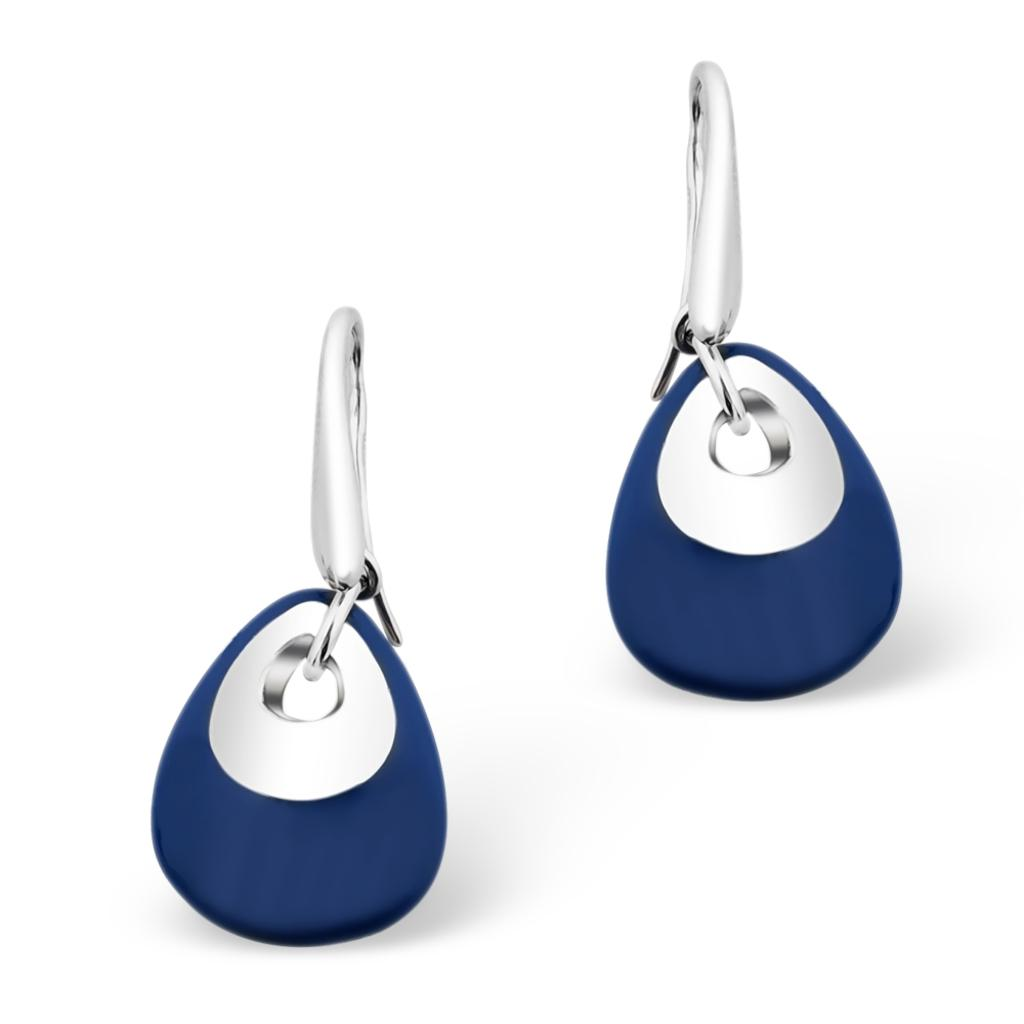What objects are in the foreground of the image? There are two earrings in the foreground of the image. What color is the background of the image? The background of the image is white. How many rabbits can be seen sitting on the cushion in the image? There are no rabbits or cushions present in the image. 